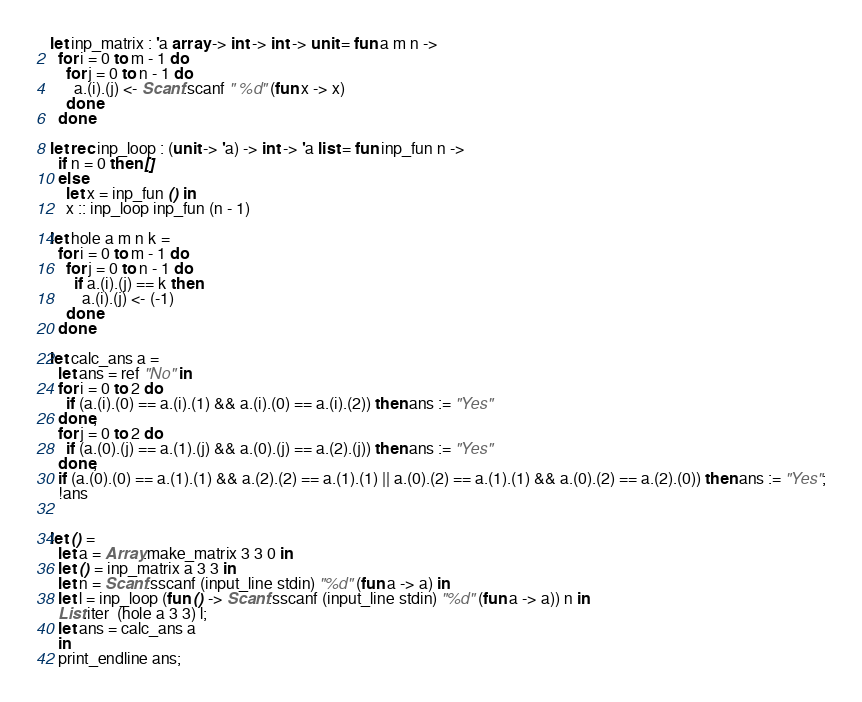<code> <loc_0><loc_0><loc_500><loc_500><_OCaml_>let inp_matrix : 'a array -> int -> int -> unit = fun a m n ->
  for i = 0 to m - 1 do
    for j = 0 to n - 1 do
      a.(i).(j) <- Scanf.scanf " %d" (fun x -> x)
    done
  done

let rec inp_loop : (unit -> 'a) -> int -> 'a list = fun inp_fun n ->
  if n = 0 then []
  else
    let x = inp_fun () in
    x :: inp_loop inp_fun (n - 1)

let hole a m n k =
  for i = 0 to m - 1 do
    for j = 0 to n - 1 do
      if a.(i).(j) == k then
        a.(i).(j) <- (-1)
    done
  done

let calc_ans a =
  let ans = ref "No" in
  for i = 0 to 2 do
    if (a.(i).(0) == a.(i).(1) && a.(i).(0) == a.(i).(2)) then ans := "Yes"
  done;
  for j = 0 to 2 do
    if (a.(0).(j) == a.(1).(j) && a.(0).(j) == a.(2).(j)) then ans := "Yes"
  done;
  if (a.(0).(0) == a.(1).(1) && a.(2).(2) == a.(1).(1) || a.(0).(2) == a.(1).(1) && a.(0).(2) == a.(2).(0)) then ans := "Yes";
  !ans
  
  
let () =
  let a = Array.make_matrix 3 3 0 in
  let () = inp_matrix a 3 3 in
  let n = Scanf.sscanf (input_line stdin) "%d" (fun a -> a) in
  let l = inp_loop (fun () -> Scanf.sscanf (input_line stdin) "%d" (fun a -> a)) n in
  List.iter  (hole a 3 3) l;
  let ans = calc_ans a
  in
  print_endline ans;
</code> 